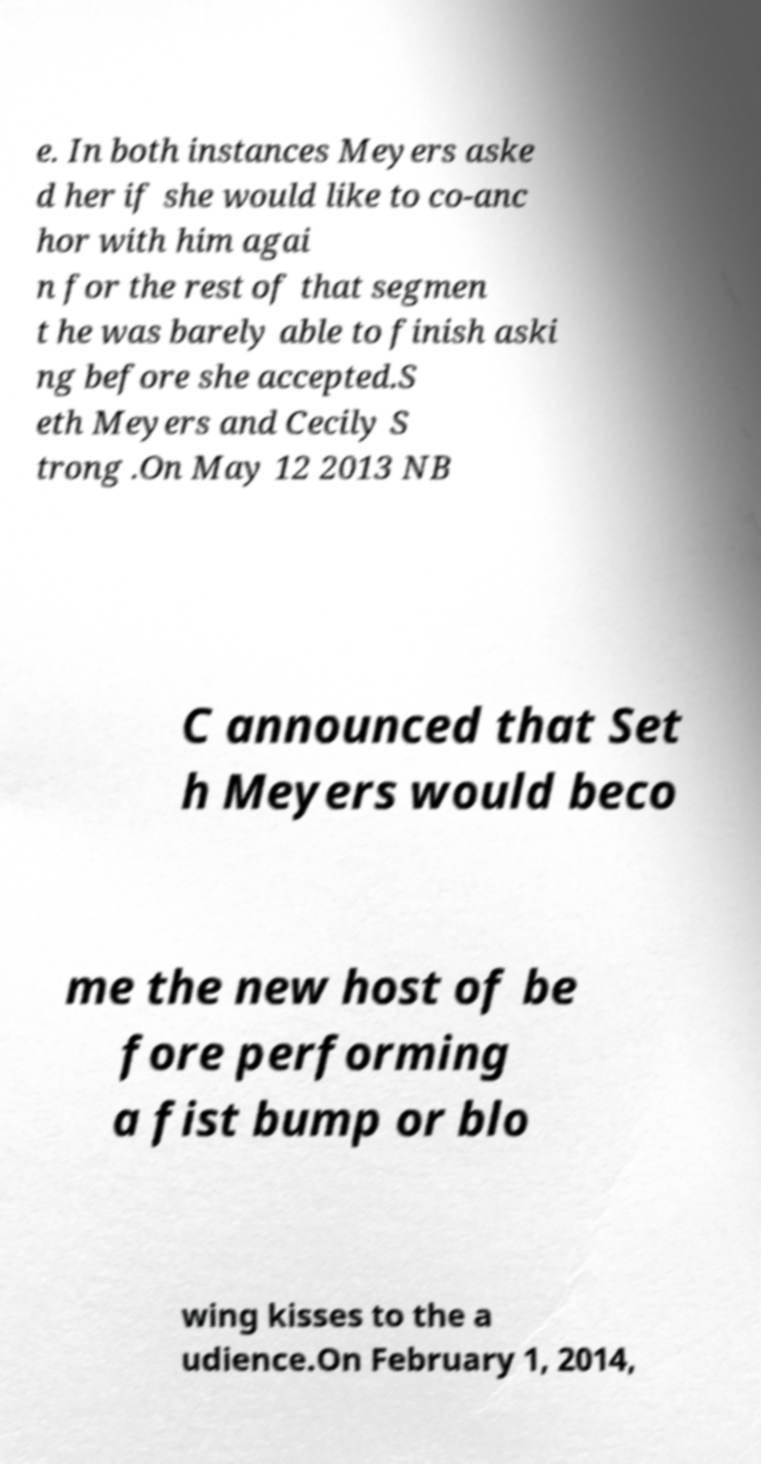I need the written content from this picture converted into text. Can you do that? e. In both instances Meyers aske d her if she would like to co-anc hor with him agai n for the rest of that segmen t he was barely able to finish aski ng before she accepted.S eth Meyers and Cecily S trong .On May 12 2013 NB C announced that Set h Meyers would beco me the new host of be fore performing a fist bump or blo wing kisses to the a udience.On February 1, 2014, 